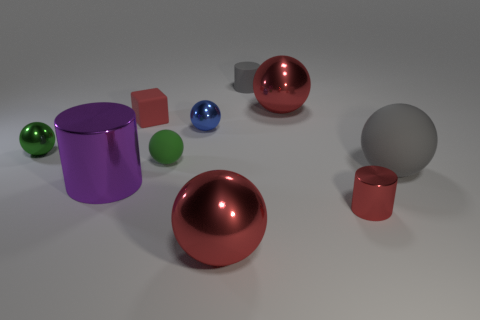Subtract 2 spheres. How many spheres are left? 4 Subtract all red balls. How many balls are left? 4 Subtract all large gray matte balls. How many balls are left? 5 Subtract all blue balls. Subtract all green cubes. How many balls are left? 5 Subtract all cylinders. How many objects are left? 7 Add 6 large gray objects. How many large gray objects exist? 7 Subtract 0 green blocks. How many objects are left? 10 Subtract all big red shiny balls. Subtract all red blocks. How many objects are left? 7 Add 9 small gray objects. How many small gray objects are left? 10 